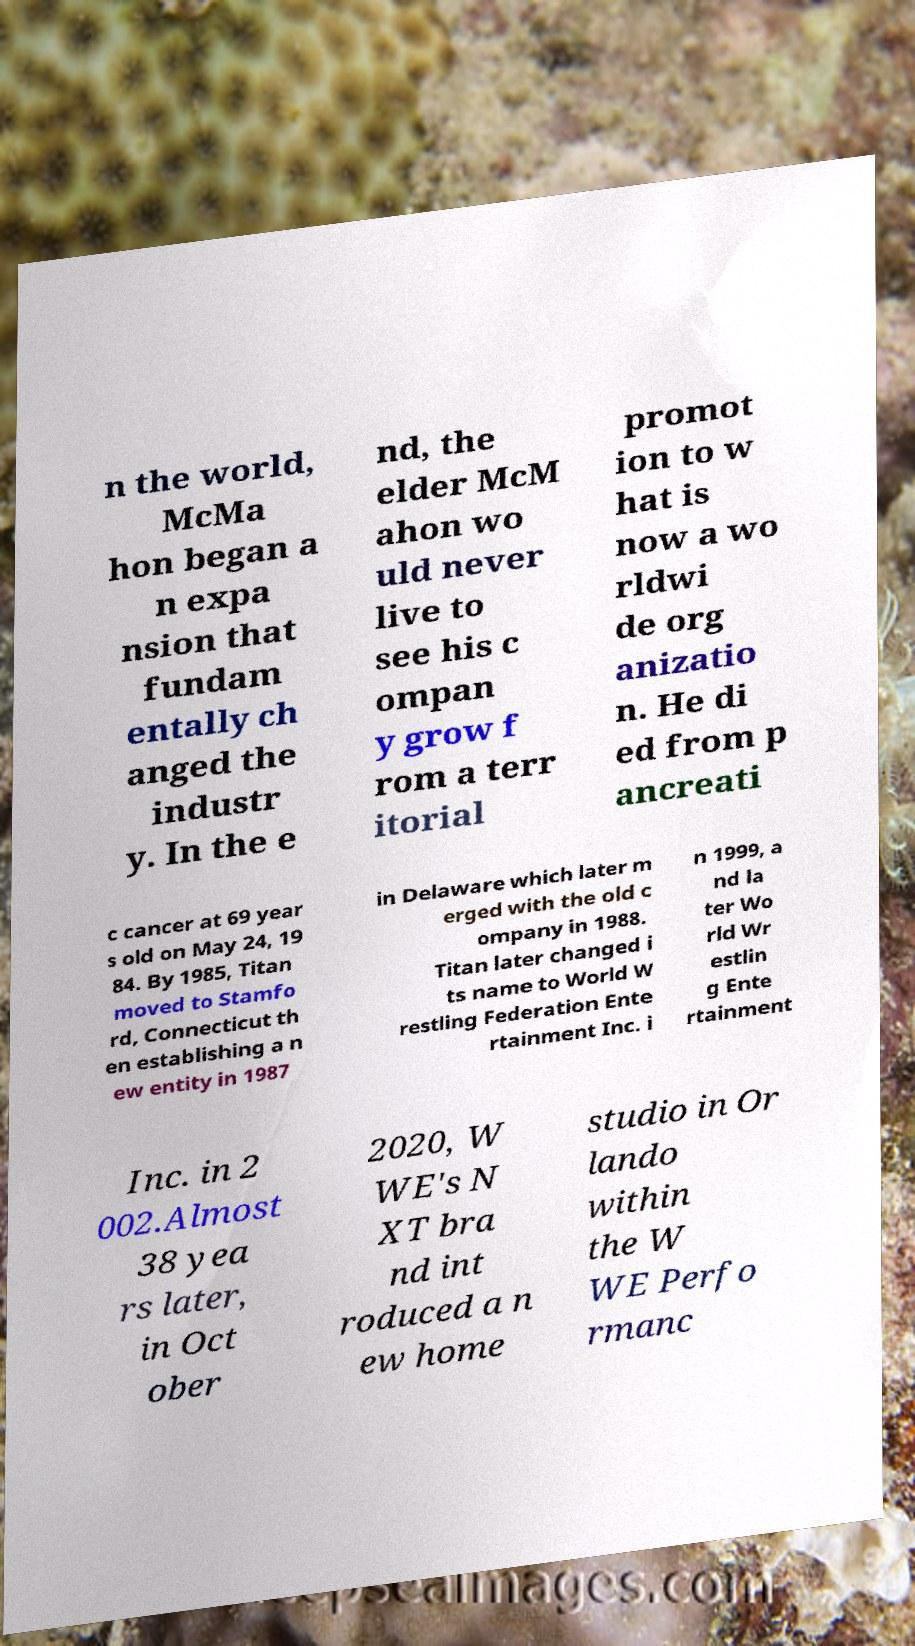Please read and relay the text visible in this image. What does it say? n the world, McMa hon began a n expa nsion that fundam entally ch anged the industr y. In the e nd, the elder McM ahon wo uld never live to see his c ompan y grow f rom a terr itorial promot ion to w hat is now a wo rldwi de org anizatio n. He di ed from p ancreati c cancer at 69 year s old on May 24, 19 84. By 1985, Titan moved to Stamfo rd, Connecticut th en establishing a n ew entity in 1987 in Delaware which later m erged with the old c ompany in 1988. Titan later changed i ts name to World W restling Federation Ente rtainment Inc. i n 1999, a nd la ter Wo rld Wr estlin g Ente rtainment Inc. in 2 002.Almost 38 yea rs later, in Oct ober 2020, W WE's N XT bra nd int roduced a n ew home studio in Or lando within the W WE Perfo rmanc 